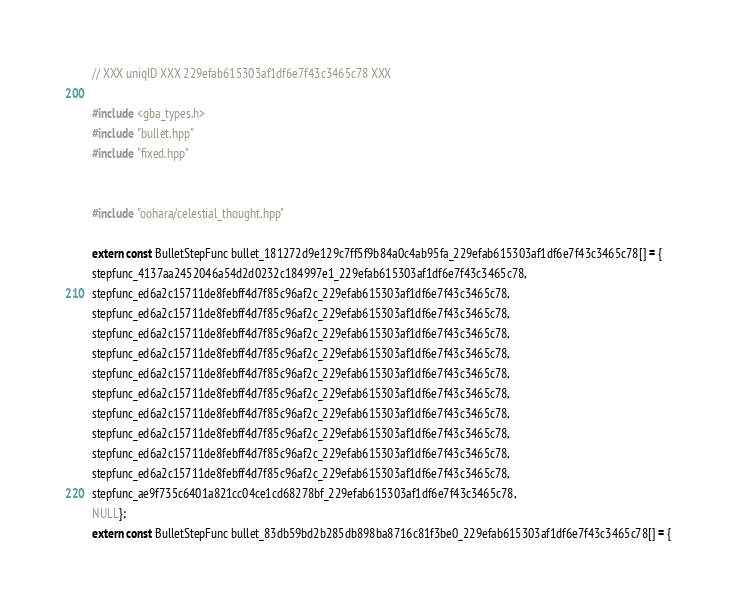Convert code to text. <code><loc_0><loc_0><loc_500><loc_500><_C++_>// XXX uniqID XXX 229efab615303af1df6e7f43c3465c78 XXX 

#include <gba_types.h>
#include "bullet.hpp"
#include "fixed.hpp"


#include "oohara/celestial_thought.hpp" 

extern const BulletStepFunc bullet_181272d9e129c7ff5f9b84a0c4ab95fa_229efab615303af1df6e7f43c3465c78[] = { 
stepfunc_4137aa2452046a54d2d0232c184997e1_229efab615303af1df6e7f43c3465c78,
stepfunc_ed6a2c15711de8febff4d7f85c96af2c_229efab615303af1df6e7f43c3465c78,
stepfunc_ed6a2c15711de8febff4d7f85c96af2c_229efab615303af1df6e7f43c3465c78,
stepfunc_ed6a2c15711de8febff4d7f85c96af2c_229efab615303af1df6e7f43c3465c78,
stepfunc_ed6a2c15711de8febff4d7f85c96af2c_229efab615303af1df6e7f43c3465c78,
stepfunc_ed6a2c15711de8febff4d7f85c96af2c_229efab615303af1df6e7f43c3465c78,
stepfunc_ed6a2c15711de8febff4d7f85c96af2c_229efab615303af1df6e7f43c3465c78,
stepfunc_ed6a2c15711de8febff4d7f85c96af2c_229efab615303af1df6e7f43c3465c78,
stepfunc_ed6a2c15711de8febff4d7f85c96af2c_229efab615303af1df6e7f43c3465c78,
stepfunc_ed6a2c15711de8febff4d7f85c96af2c_229efab615303af1df6e7f43c3465c78,
stepfunc_ed6a2c15711de8febff4d7f85c96af2c_229efab615303af1df6e7f43c3465c78,
stepfunc_ae9f735c6401a821cc04ce1cd68278bf_229efab615303af1df6e7f43c3465c78,
NULL}; 
extern const BulletStepFunc bullet_83db59bd2b285db898ba8716c81f3be0_229efab615303af1df6e7f43c3465c78[] = { </code> 